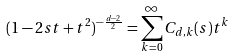<formula> <loc_0><loc_0><loc_500><loc_500>( 1 - 2 s t + t ^ { 2 } ) ^ { - \frac { d - 2 } { 2 } } = \sum _ { k = 0 } ^ { \infty } C _ { d , k } ( s ) t ^ { k }</formula> 